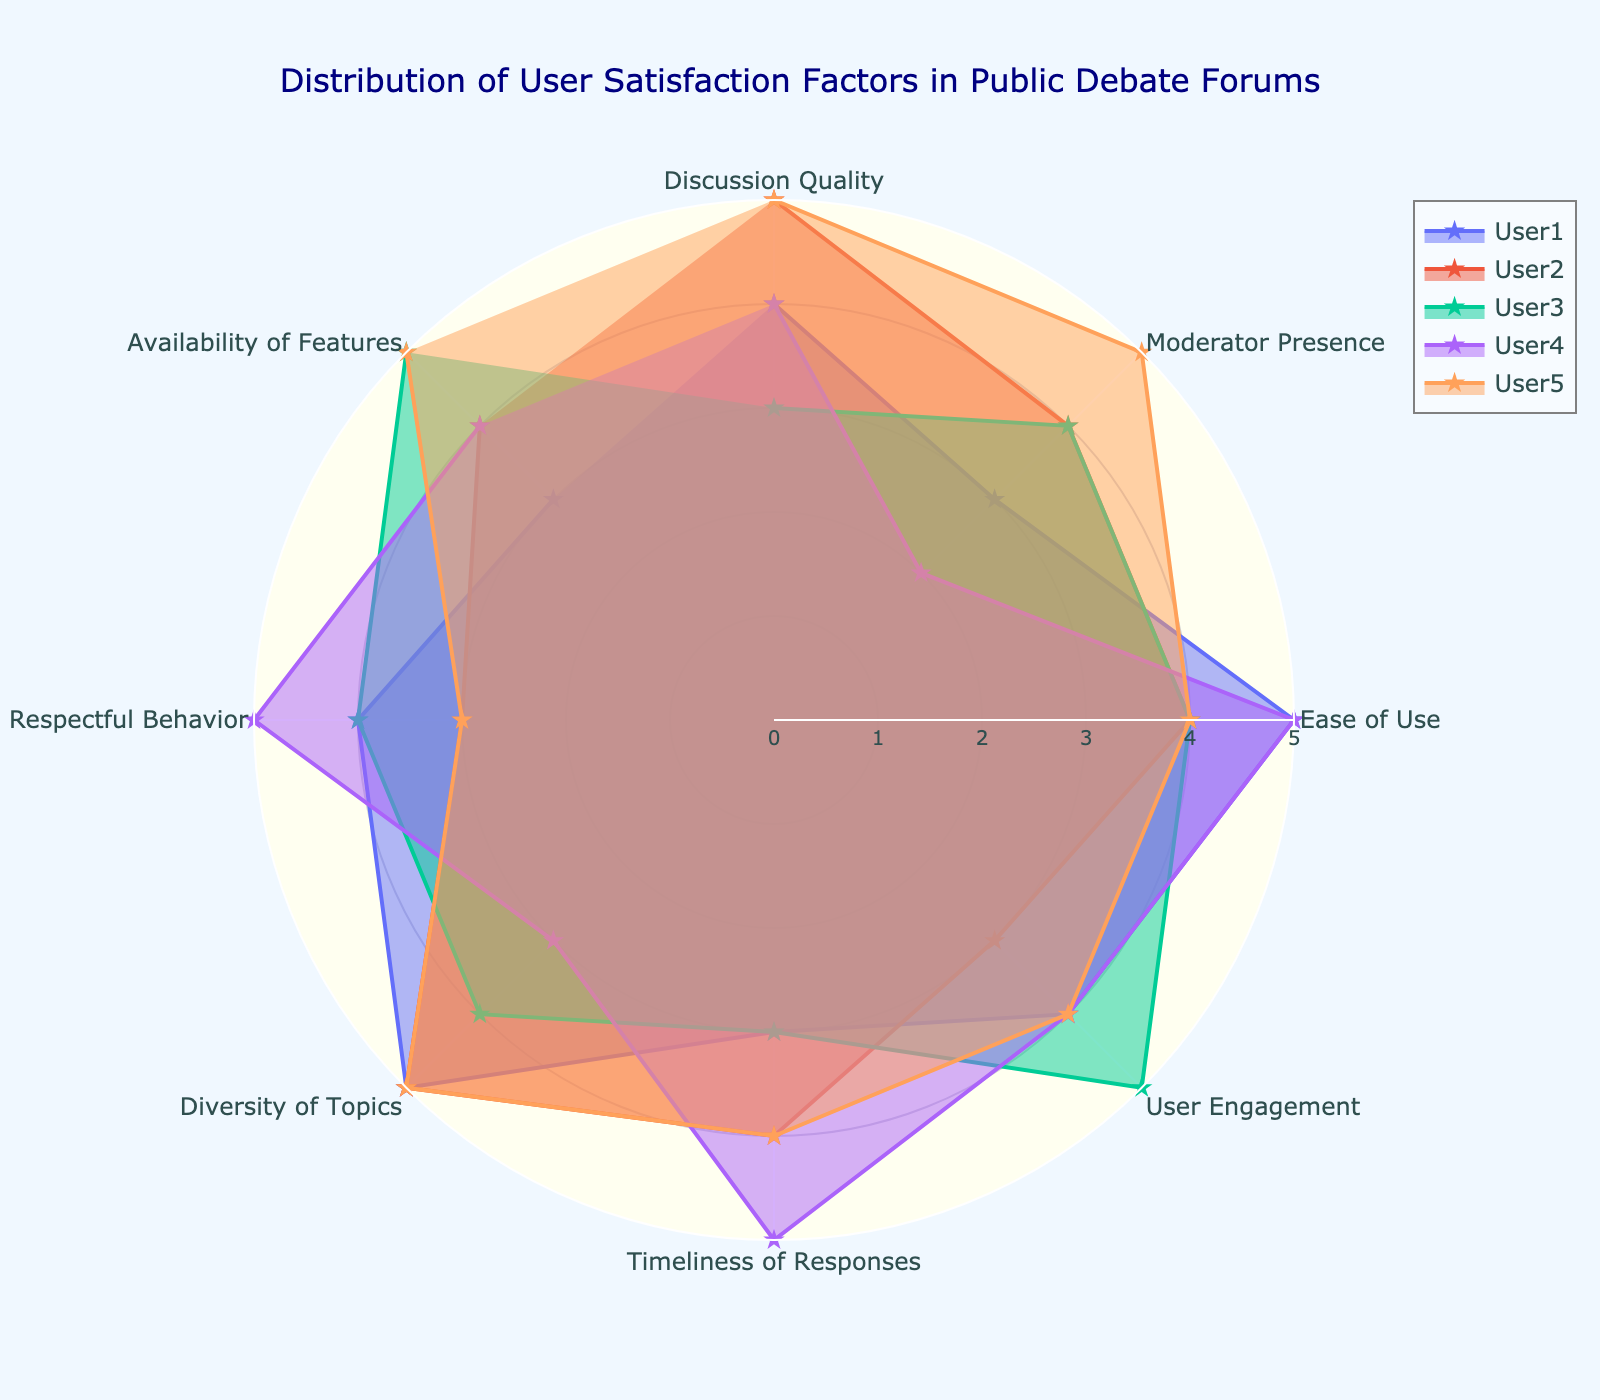What is the title of the radar chart? The title of the chart is located at the top and gives an overview of what the chart represents. It reads "Distribution of User Satisfaction Factors in Public Debate Forums."
Answer: Distribution of User Satisfaction Factors in Public Debate Forums How many categories are displayed in the radar chart? Counting the labels around the circumference of the radar chart, you can see there are eight categories.
Answer: Eight Which user has the highest rating for the category "Ease of Use"? Looking at the "Ease of Use" division on the chart, User1 and User4 both have the highest rating of 5.
Answer: User1 and User4 What is the average rating for the "Respectful Behavior" category across all users? The ratings for "Respectful Behavior" are 4, 3, 4, 5, 3. Summing these values gives 19, and dividing by the number of users (5) gives 3.8.
Answer: 3.8 Between the categories "Moderator Presence" and "Timeliness of Responses," which one seems to have a higher overall user satisfaction? For "Moderator Presence," the values are 3, 4, 4, 2, 5, and for "Timeliness of Responses," the values are 3, 4, 3, 5, 4. Adding each category gives 18 (Moderator Presence) and 19 (Timeliness of Responses). The average is slightly higher for "Timeliness of Responses."
Answer: Timeliness of Responses Which user has the most uniformly distributed satisfaction across all categories? By observing the shapes of the plots, User3's ratings appear to be more evenly spread across various categories without large peaks or dips.
Answer: User3 What is the total score for User2 across all categories? Adding the ratings for User2 across all categories: 5 (Discussion Quality) + 4 (Moderator Presence) + 4 (Ease of Use) + 3 (User Engagement) + 4 (Timeliness of Responses) + 5 (Diversity of Topics) + 3 (Respectful Behavior) + 4 (Availability of Features), we get 32.
Answer: 32 Which category has the highest variance in user satisfaction ratings? A quick look shows the "Respectful Behavior" category has ratings of 4, 3, 4, 5, 3, creating a noticeable spread between high and low ratings.
Answer: Respectful Behavior How does User5's rating for "Medium of Discussion" compare to other categories for the same user? There's no "Medium of Discussion" category available to compare in the dataset, making this an invalid query. This points out the importance of validating categories before asking questions.
Answer: N/A 